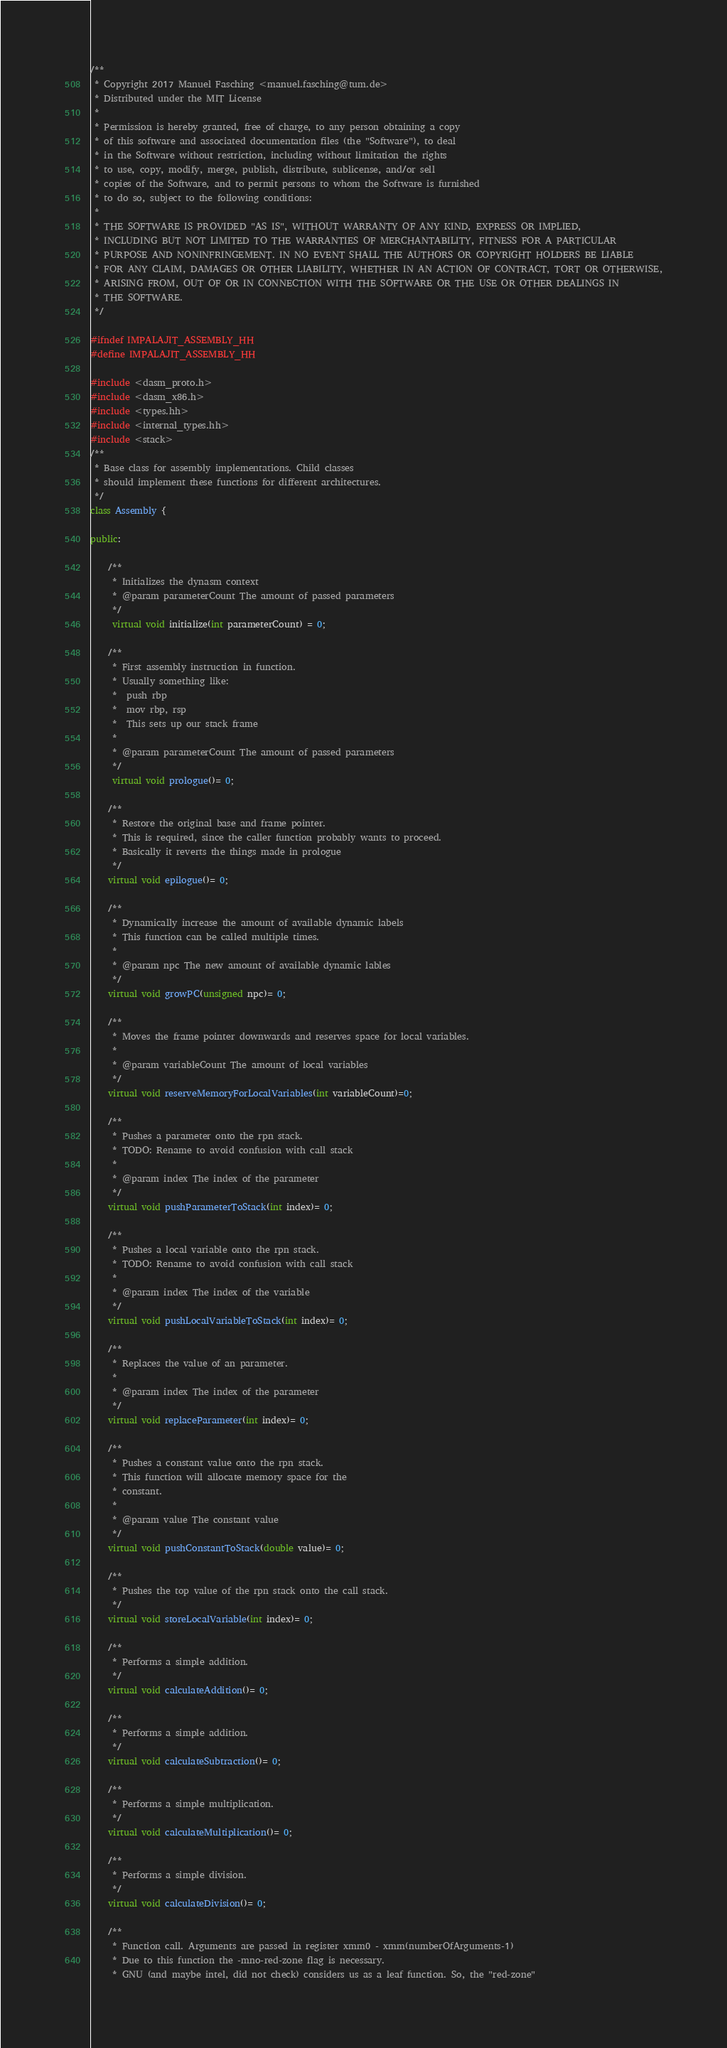<code> <loc_0><loc_0><loc_500><loc_500><_C++_>/**
 * Copyright 2017 Manuel Fasching <manuel.fasching@tum.de>
 * Distributed under the MIT License
 *
 * Permission is hereby granted, free of charge, to any person obtaining a copy
 * of this software and associated documentation files (the "Software"), to deal
 * in the Software without restriction, including without limitation the rights
 * to use, copy, modify, merge, publish, distribute, sublicense, and/or sell
 * copies of the Software, and to permit persons to whom the Software is furnished
 * to do so, subject to the following conditions:
 *
 * THE SOFTWARE IS PROVIDED "AS IS", WITHOUT WARRANTY OF ANY KIND, EXPRESS OR IMPLIED,
 * INCLUDING BUT NOT LIMITED TO THE WARRANTIES OF MERCHANTABILITY, FITNESS FOR A PARTICULAR
 * PURPOSE AND NONINFRINGEMENT. IN NO EVENT SHALL THE AUTHORS OR COPYRIGHT HOLDERS BE LIABLE
 * FOR ANY CLAIM, DAMAGES OR OTHER LIABILITY, WHETHER IN AN ACTION OF CONTRACT, TORT OR OTHERWISE,
 * ARISING FROM, OUT OF OR IN CONNECTION WITH THE SOFTWARE OR THE USE OR OTHER DEALINGS IN
 * THE SOFTWARE.
 */

#ifndef IMPALAJIT_ASSEMBLY_HH
#define IMPALAJIT_ASSEMBLY_HH

#include <dasm_proto.h>
#include <dasm_x86.h>
#include <types.hh>
#include <internal_types.hh>
#include <stack>
/**
 * Base class for assembly implementations. Child classes
 * should implement these functions for different architectures.
 */
class Assembly {

public:

    /**
     * Initializes the dynasm context
     * @param parameterCount The amount of passed parameters
     */
     virtual void initialize(int parameterCount) = 0;

    /**
     * First assembly instruction in function.
     * Usually something like:
     *  push rbp
     *  mov rbp, rsp
     *  This sets up our stack frame
     *
     * @param parameterCount The amount of passed parameters
     */
     virtual void prologue()= 0;

    /**
     * Restore the original base and frame pointer.
     * This is required, since the caller function probably wants to proceed.
     * Basically it reverts the things made in prologue
     */
    virtual void epilogue()= 0;

    /**
     * Dynamically increase the amount of available dynamic labels
     * This function can be called multiple times.
     *
     * @param npc The new amount of available dynamic lables
     */
    virtual void growPC(unsigned npc)= 0;

    /**
     * Moves the frame pointer downwards and reserves space for local variables.
     *
     * @param variableCount The amount of local variables
     */
    virtual void reserveMemoryForLocalVariables(int variableCount)=0;

    /**
     * Pushes a parameter onto the rpn stack.
     * TODO: Rename to avoid confusion with call stack
     *
     * @param index The index of the parameter
     */
    virtual void pushParameterToStack(int index)= 0;

    /**
     * Pushes a local variable onto the rpn stack.
     * TODO: Rename to avoid confusion with call stack
     *
     * @param index The index of the variable
     */
    virtual void pushLocalVariableToStack(int index)= 0;

    /**
     * Replaces the value of an parameter.
     *
     * @param index The index of the parameter
     */
    virtual void replaceParameter(int index)= 0;

    /**
     * Pushes a constant value onto the rpn stack.
     * This function will allocate memory space for the
     * constant.
     *
     * @param value The constant value
     */
    virtual void pushConstantToStack(double value)= 0;

    /**
     * Pushes the top value of the rpn stack onto the call stack.
     */
    virtual void storeLocalVariable(int index)= 0;

    /**
     * Performs a simple addition.
     */
    virtual void calculateAddition()= 0;

    /**
     * Performs a simple addition.
     */
    virtual void calculateSubtraction()= 0;

    /**
     * Performs a simple multiplication.
     */
    virtual void calculateMultiplication()= 0;

    /**
     * Performs a simple division.
     */
    virtual void calculateDivision()= 0;

    /**
     * Function call. Arguments are passed in register xmm0 - xmm(numberOfArguments-1)
     * Due to this function the -mno-red-zone flag is necessary.
     * GNU (and maybe intel, did not check) considers us as a leaf function. So, the "red-zone"</code> 